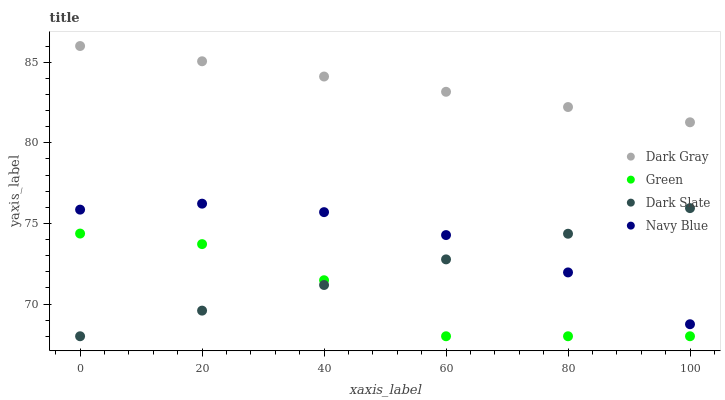Does Green have the minimum area under the curve?
Answer yes or no. Yes. Does Dark Gray have the maximum area under the curve?
Answer yes or no. Yes. Does Dark Slate have the minimum area under the curve?
Answer yes or no. No. Does Dark Slate have the maximum area under the curve?
Answer yes or no. No. Is Dark Slate the smoothest?
Answer yes or no. Yes. Is Green the roughest?
Answer yes or no. Yes. Is Green the smoothest?
Answer yes or no. No. Is Dark Slate the roughest?
Answer yes or no. No. Does Dark Slate have the lowest value?
Answer yes or no. Yes. Does Navy Blue have the lowest value?
Answer yes or no. No. Does Dark Gray have the highest value?
Answer yes or no. Yes. Does Dark Slate have the highest value?
Answer yes or no. No. Is Navy Blue less than Dark Gray?
Answer yes or no. Yes. Is Dark Gray greater than Navy Blue?
Answer yes or no. Yes. Does Dark Slate intersect Navy Blue?
Answer yes or no. Yes. Is Dark Slate less than Navy Blue?
Answer yes or no. No. Is Dark Slate greater than Navy Blue?
Answer yes or no. No. Does Navy Blue intersect Dark Gray?
Answer yes or no. No. 